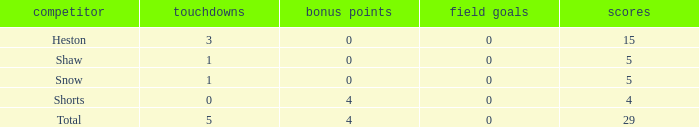What is the total number of field goals for a player that had less than 3 touchdowns, had 4 points, and had less than 4 extra points? 0.0. 